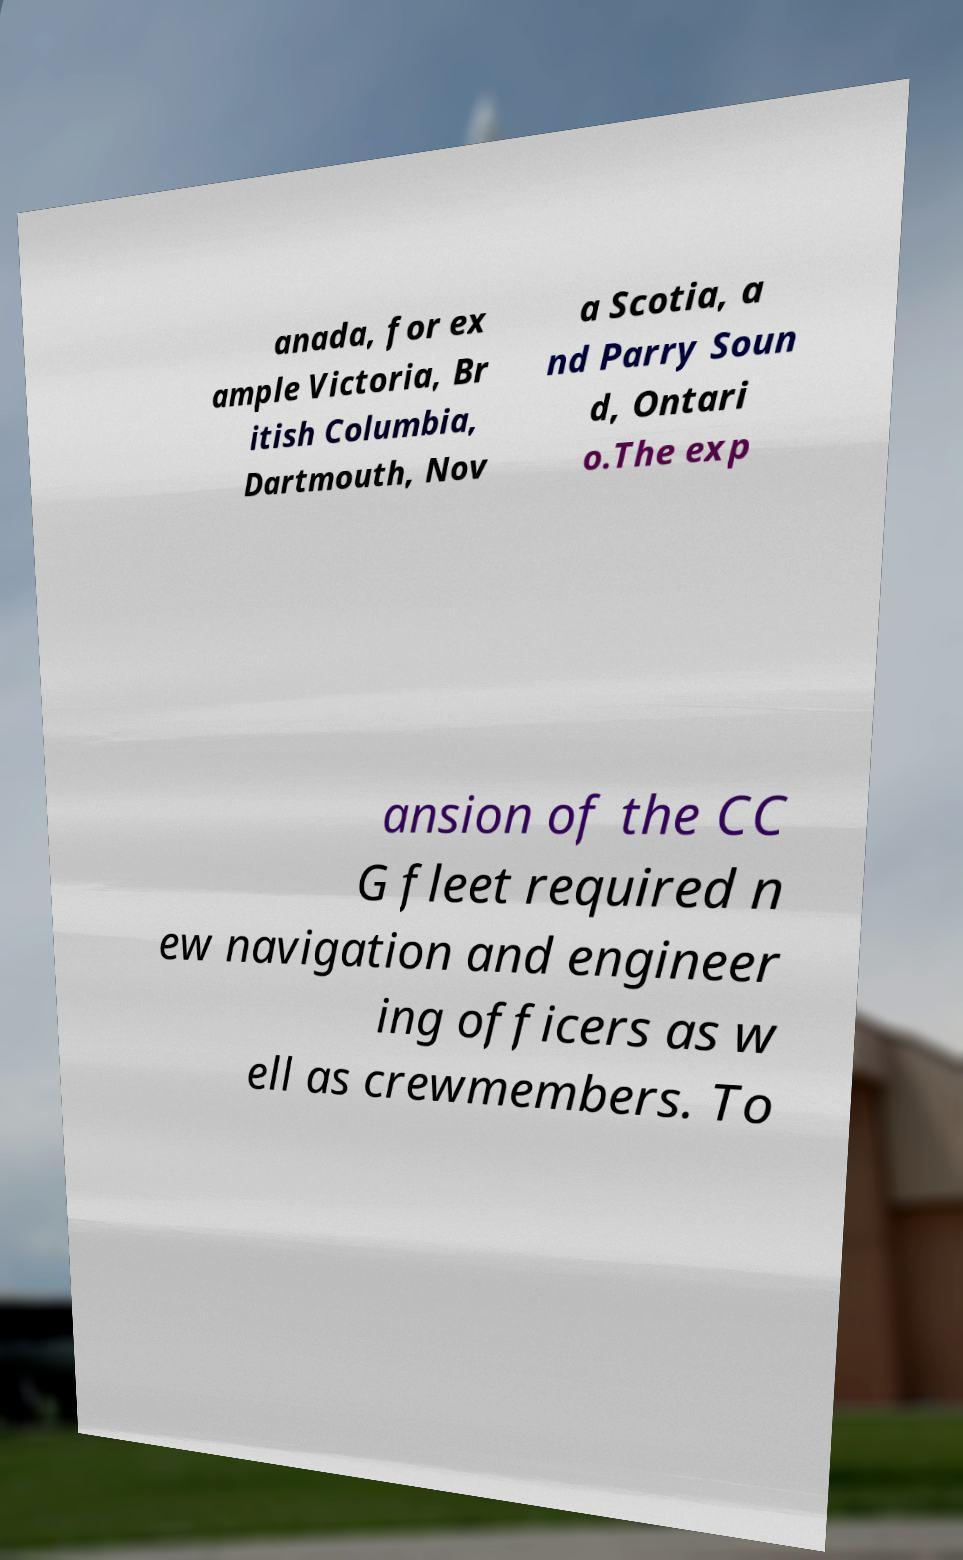Please read and relay the text visible in this image. What does it say? anada, for ex ample Victoria, Br itish Columbia, Dartmouth, Nov a Scotia, a nd Parry Soun d, Ontari o.The exp ansion of the CC G fleet required n ew navigation and engineer ing officers as w ell as crewmembers. To 